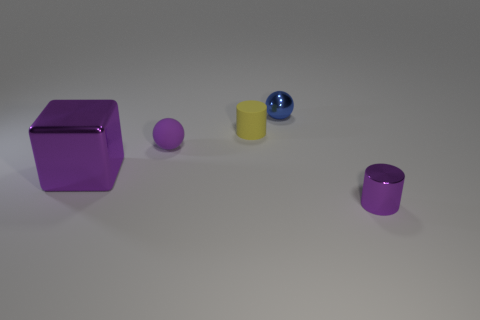Do the cylinder that is to the right of the blue shiny sphere and the tiny metal object that is behind the shiny cylinder have the same color? no 